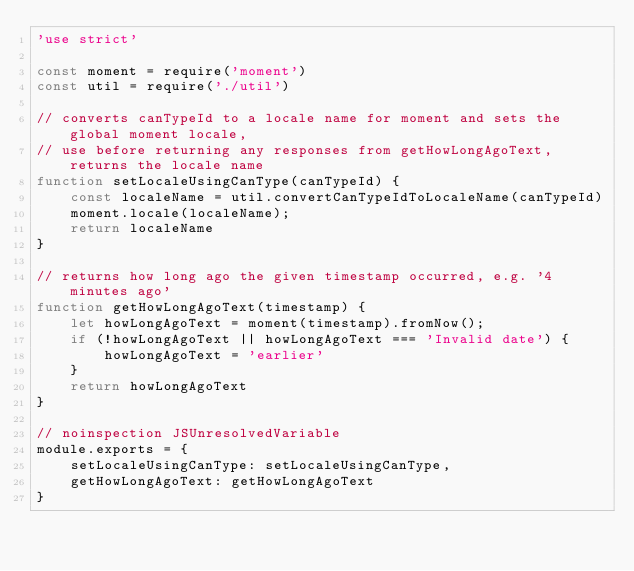<code> <loc_0><loc_0><loc_500><loc_500><_JavaScript_>'use strict'

const moment = require('moment')
const util = require('./util')

// converts canTypeId to a locale name for moment and sets the global moment locale,
// use before returning any responses from getHowLongAgoText, returns the locale name
function setLocaleUsingCanType(canTypeId) {
    const localeName = util.convertCanTypeIdToLocaleName(canTypeId)
    moment.locale(localeName);
    return localeName
}

// returns how long ago the given timestamp occurred, e.g. '4 minutes ago'
function getHowLongAgoText(timestamp) {
    let howLongAgoText = moment(timestamp).fromNow();
    if (!howLongAgoText || howLongAgoText === 'Invalid date') {
        howLongAgoText = 'earlier'
    }
    return howLongAgoText
}

// noinspection JSUnresolvedVariable
module.exports = {
    setLocaleUsingCanType: setLocaleUsingCanType,
    getHowLongAgoText: getHowLongAgoText
}
</code> 